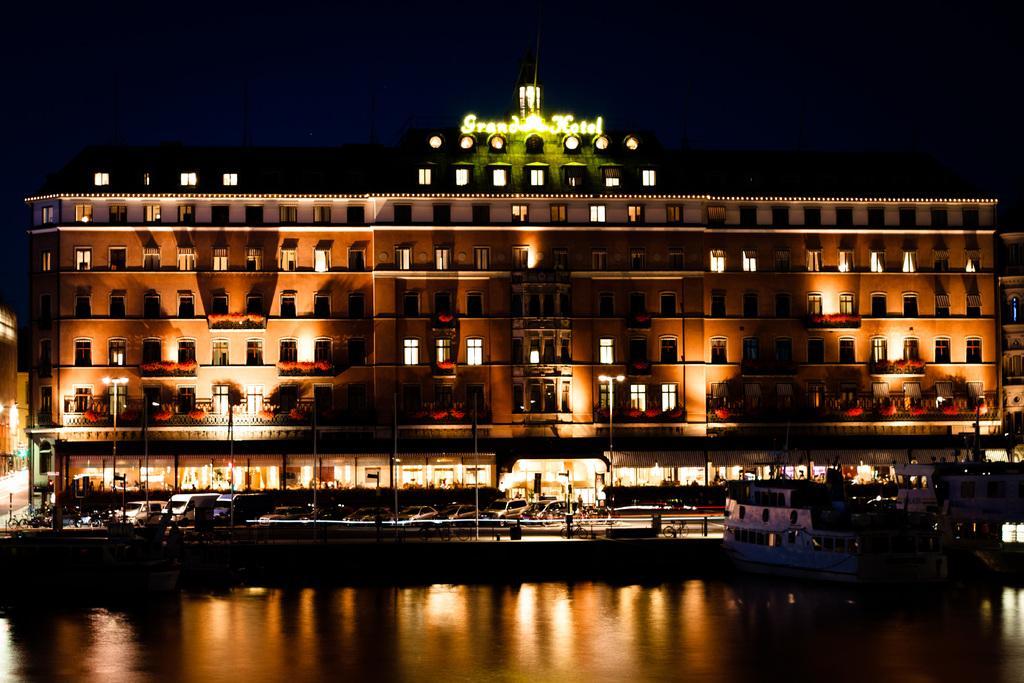In one or two sentences, can you explain what this image depicts? In this image we can see a building and there are some vehicles on the road and to the side we can see some street lights. At the bottom we can see the water body and there are some boats and we can see the sky at the top. 